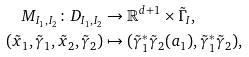<formula> <loc_0><loc_0><loc_500><loc_500>M _ { I _ { 1 } , I _ { 2 } } \colon D _ { I _ { 1 } , I _ { 2 } } & \to \mathbb { R } ^ { d + 1 } \times \tilde { \Gamma } _ { I } , \\ ( \tilde { x } _ { 1 } , \tilde { \gamma } _ { 1 } , \tilde { x } _ { 2 } , \tilde { \gamma } _ { 2 } ) & \mapsto ( \tilde { \gamma } _ { 1 } ^ { * } \tilde { \gamma } _ { 2 } ( a _ { 1 } ) , \tilde { \gamma } _ { 1 } ^ { * } \tilde { \gamma } _ { 2 } ) ,</formula> 